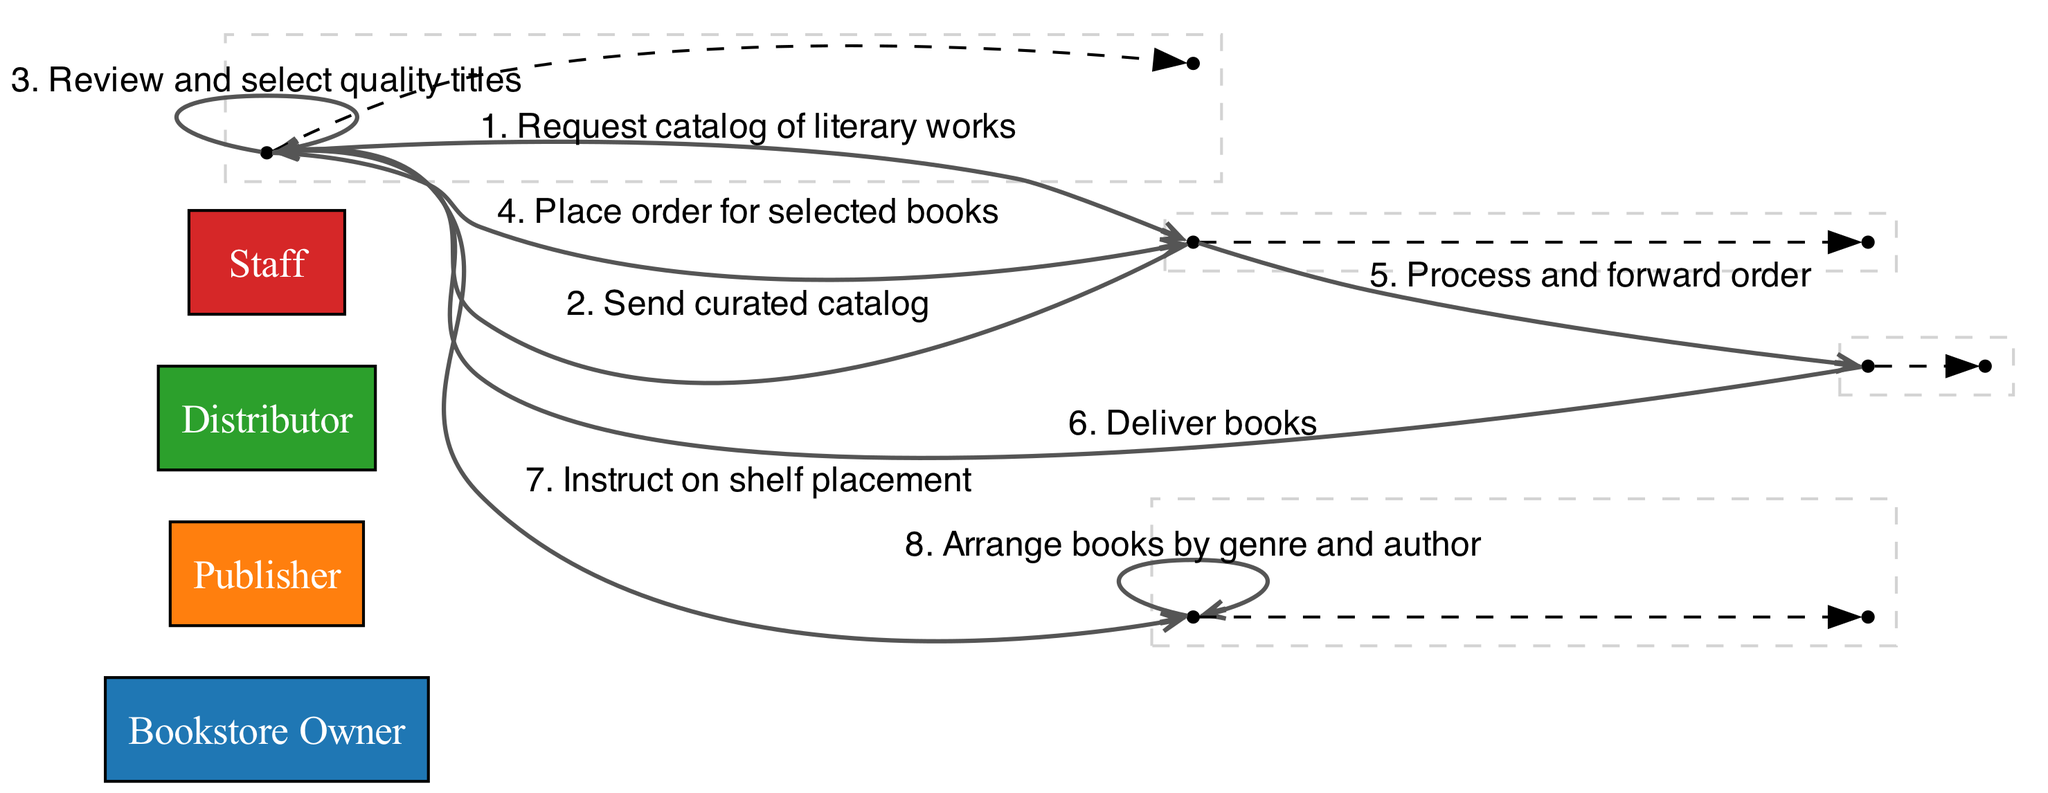What is the first message sent in the diagram? The first message is sent from the Bookstore Owner to the Publisher, requesting a catalog. Thus, the first message is "Request catalog of literary works."
Answer: Request catalog of literary works Who sends the curated catalog? The Publisher is responsible for sending the curated catalog to the Bookstore Owner. Hence, the entity sending the catalog is the Publisher.
Answer: Publisher How many actors are involved in this process? The actors mentioned in the diagram include the Bookstore Owner, Publisher, Distributor, and Staff. Counting them gives a total of four actors involved in the process.
Answer: Four Which actor delivers the books to the Bookstore Owner? The entity responsible for delivering the books is the Distributor, as indicated in the sequence where the Distributor sends books to the Bookstore Owner.
Answer: Distributor What action does the Bookstore Owner take after reviewing the catalog? After reviewing the catalog, the Bookstore Owner selects quality titles. This is a key step following the review of the curated catalog.
Answer: Review and select quality titles What is the last step in the ordering process depicted in the diagram? The final step occurs when the Staff arranges the books by genre and author after receiving instructions from the Bookstore Owner. This indicates the completion of the ordering process.
Answer: Arrange books by genre and author What message is sent from the Publisher to the Distributor? The Publisher processes and forwards the order received from the Bookstore Owner to the Distributor. This exchange represents an essential part of fulfilling the order.
Answer: Process and forward order Who receives instructions for shelf placement? The instructions for shelf placement are given to the Staff by the Bookstore Owner, directing how the books should be organized once delivered.
Answer: Staff 